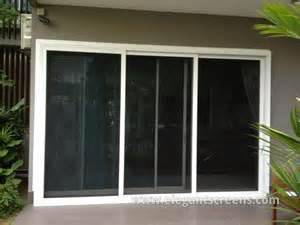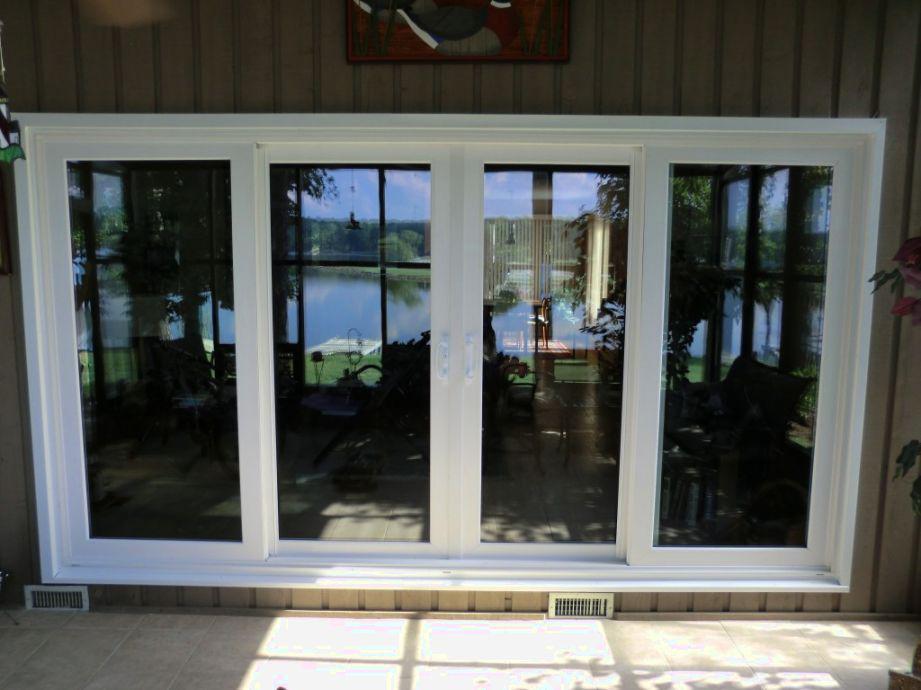The first image is the image on the left, the second image is the image on the right. For the images shown, is this caption "A floor mat sits outside one of the doors." true? Answer yes or no. No. 